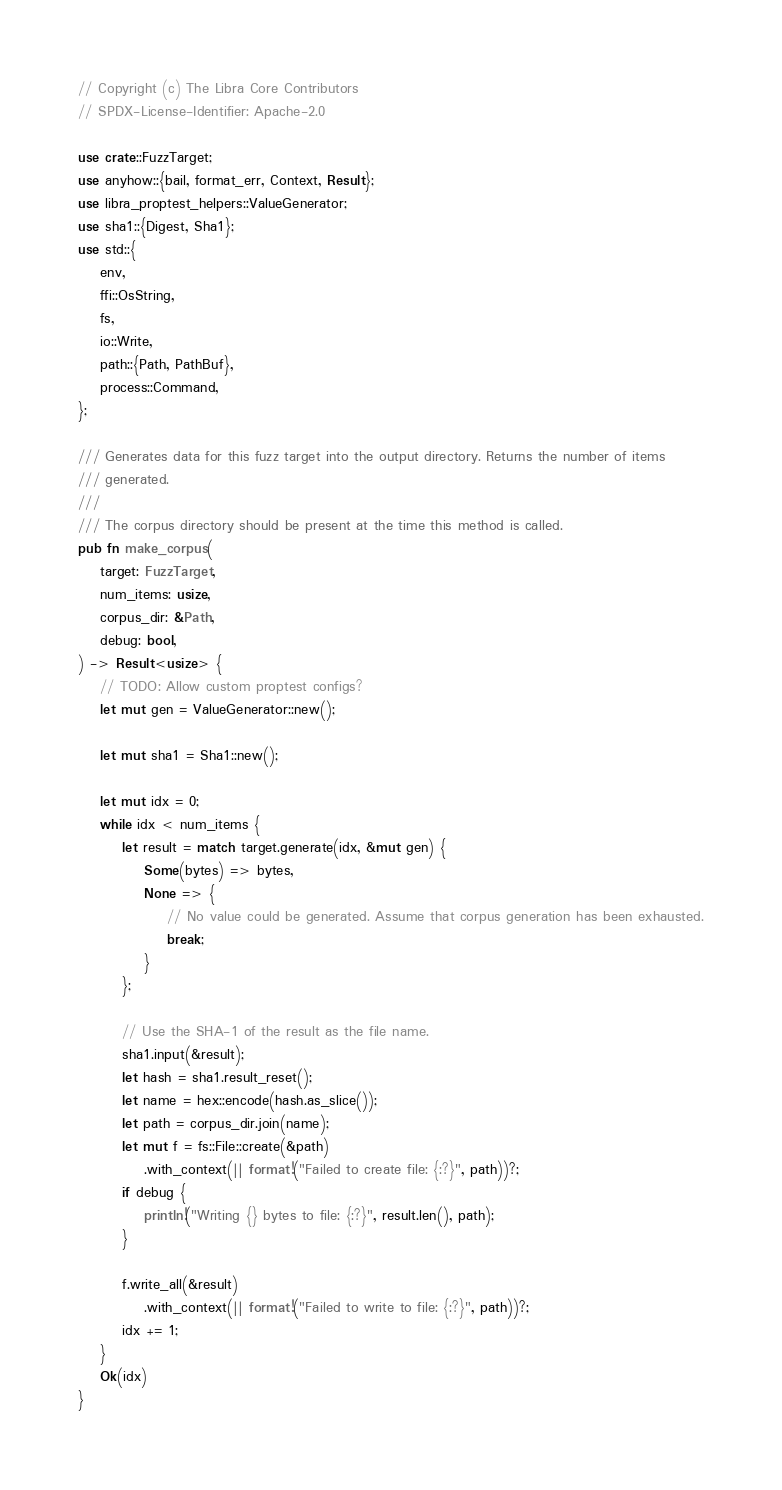<code> <loc_0><loc_0><loc_500><loc_500><_Rust_>// Copyright (c) The Libra Core Contributors
// SPDX-License-Identifier: Apache-2.0

use crate::FuzzTarget;
use anyhow::{bail, format_err, Context, Result};
use libra_proptest_helpers::ValueGenerator;
use sha1::{Digest, Sha1};
use std::{
    env,
    ffi::OsString,
    fs,
    io::Write,
    path::{Path, PathBuf},
    process::Command,
};

/// Generates data for this fuzz target into the output directory. Returns the number of items
/// generated.
///
/// The corpus directory should be present at the time this method is called.
pub fn make_corpus(
    target: FuzzTarget,
    num_items: usize,
    corpus_dir: &Path,
    debug: bool,
) -> Result<usize> {
    // TODO: Allow custom proptest configs?
    let mut gen = ValueGenerator::new();

    let mut sha1 = Sha1::new();

    let mut idx = 0;
    while idx < num_items {
        let result = match target.generate(idx, &mut gen) {
            Some(bytes) => bytes,
            None => {
                // No value could be generated. Assume that corpus generation has been exhausted.
                break;
            }
        };

        // Use the SHA-1 of the result as the file name.
        sha1.input(&result);
        let hash = sha1.result_reset();
        let name = hex::encode(hash.as_slice());
        let path = corpus_dir.join(name);
        let mut f = fs::File::create(&path)
            .with_context(|| format!("Failed to create file: {:?}", path))?;
        if debug {
            println!("Writing {} bytes to file: {:?}", result.len(), path);
        }

        f.write_all(&result)
            .with_context(|| format!("Failed to write to file: {:?}", path))?;
        idx += 1;
    }
    Ok(idx)
}
</code> 